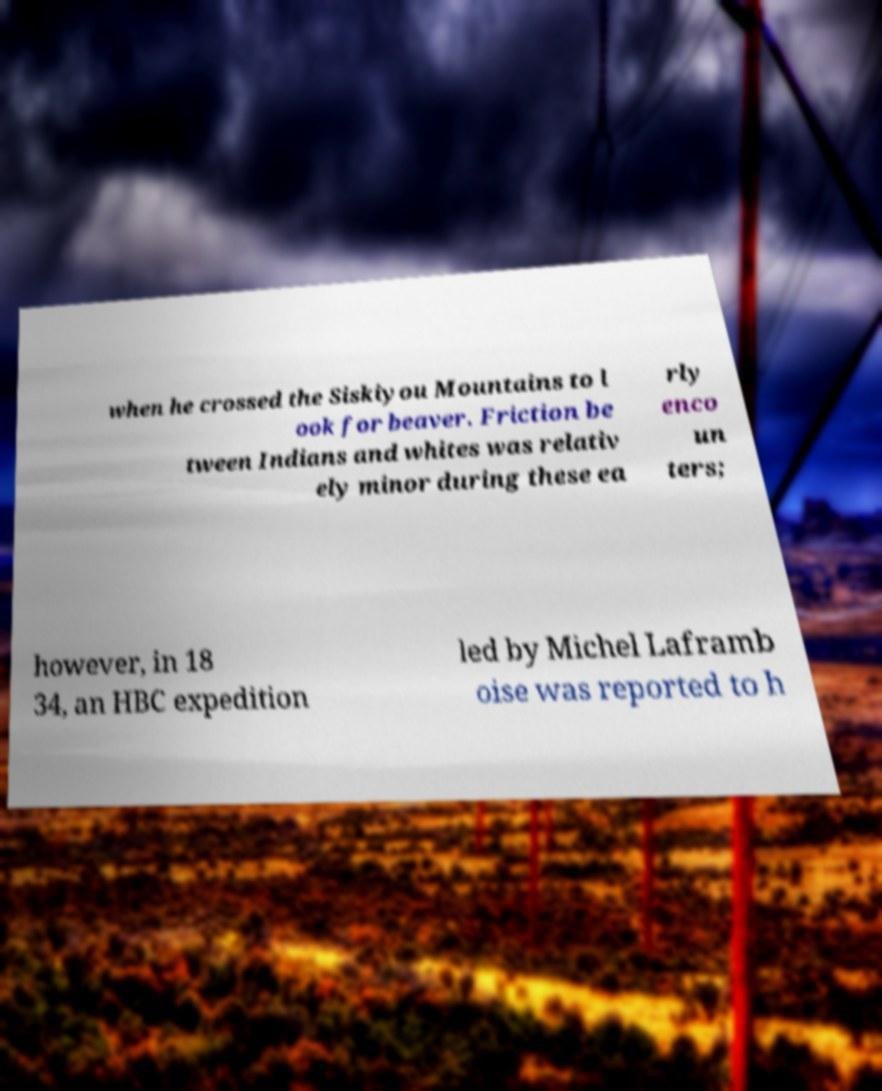Can you accurately transcribe the text from the provided image for me? when he crossed the Siskiyou Mountains to l ook for beaver. Friction be tween Indians and whites was relativ ely minor during these ea rly enco un ters; however, in 18 34, an HBC expedition led by Michel Laframb oise was reported to h 